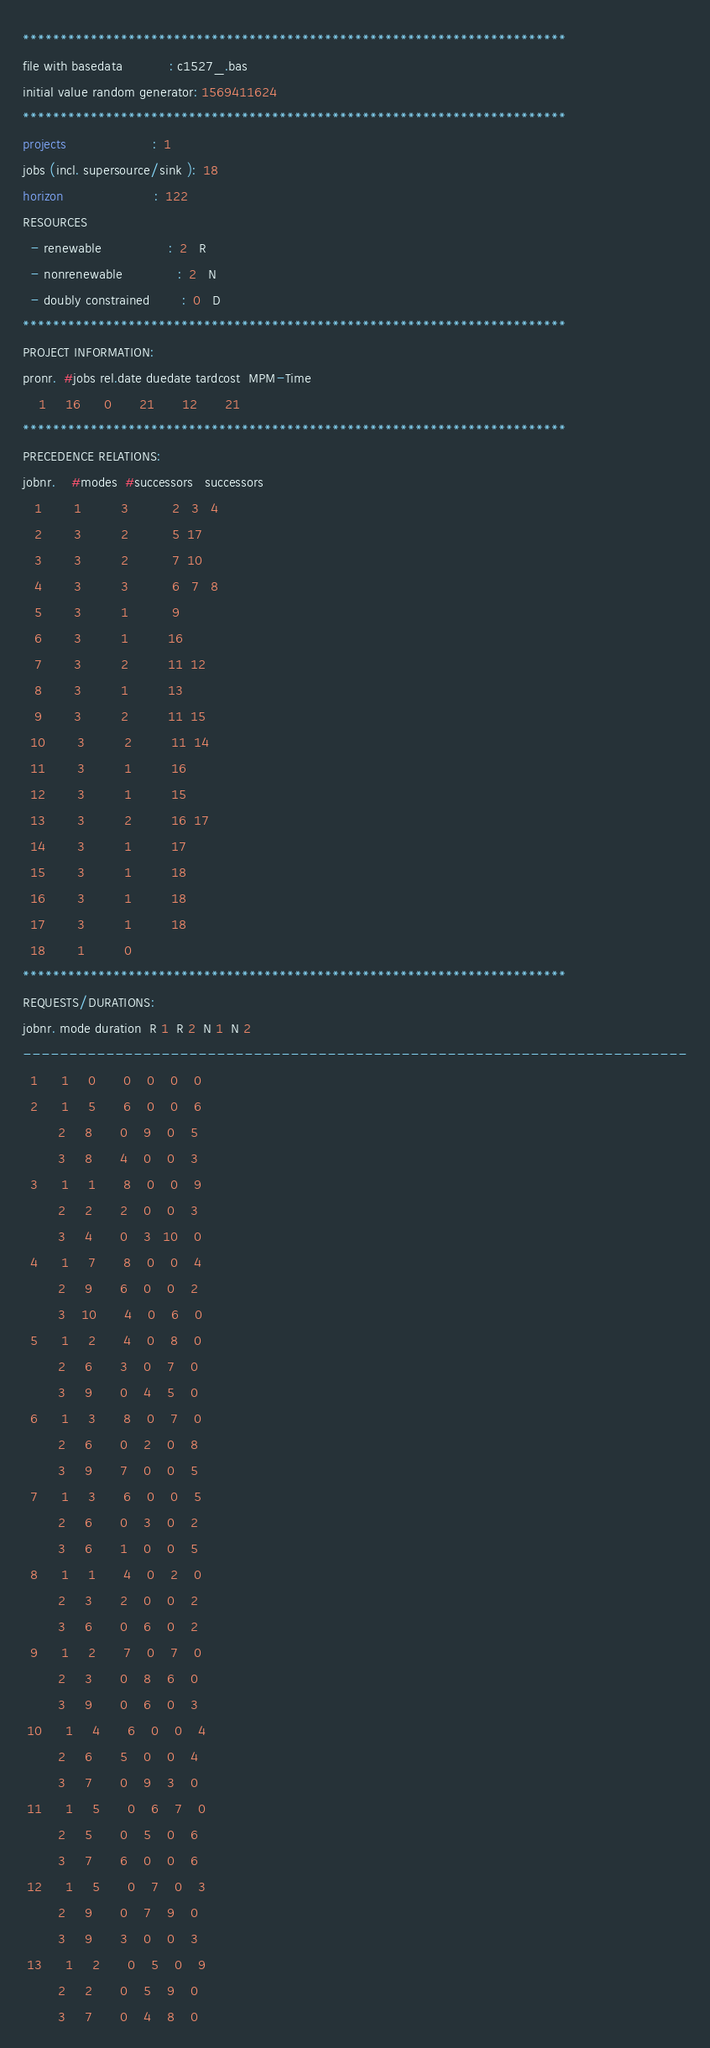<code> <loc_0><loc_0><loc_500><loc_500><_ObjectiveC_>************************************************************************
file with basedata            : c1527_.bas
initial value random generator: 1569411624
************************************************************************
projects                      :  1
jobs (incl. supersource/sink ):  18
horizon                       :  122
RESOURCES
  - renewable                 :  2   R
  - nonrenewable              :  2   N
  - doubly constrained        :  0   D
************************************************************************
PROJECT INFORMATION:
pronr.  #jobs rel.date duedate tardcost  MPM-Time
    1     16      0       21       12       21
************************************************************************
PRECEDENCE RELATIONS:
jobnr.    #modes  #successors   successors
   1        1          3           2   3   4
   2        3          2           5  17
   3        3          2           7  10
   4        3          3           6   7   8
   5        3          1           9
   6        3          1          16
   7        3          2          11  12
   8        3          1          13
   9        3          2          11  15
  10        3          2          11  14
  11        3          1          16
  12        3          1          15
  13        3          2          16  17
  14        3          1          17
  15        3          1          18
  16        3          1          18
  17        3          1          18
  18        1          0        
************************************************************************
REQUESTS/DURATIONS:
jobnr. mode duration  R 1  R 2  N 1  N 2
------------------------------------------------------------------------
  1      1     0       0    0    0    0
  2      1     5       6    0    0    6
         2     8       0    9    0    5
         3     8       4    0    0    3
  3      1     1       8    0    0    9
         2     2       2    0    0    3
         3     4       0    3   10    0
  4      1     7       8    0    0    4
         2     9       6    0    0    2
         3    10       4    0    6    0
  5      1     2       4    0    8    0
         2     6       3    0    7    0
         3     9       0    4    5    0
  6      1     3       8    0    7    0
         2     6       0    2    0    8
         3     9       7    0    0    5
  7      1     3       6    0    0    5
         2     6       0    3    0    2
         3     6       1    0    0    5
  8      1     1       4    0    2    0
         2     3       2    0    0    2
         3     6       0    6    0    2
  9      1     2       7    0    7    0
         2     3       0    8    6    0
         3     9       0    6    0    3
 10      1     4       6    0    0    4
         2     6       5    0    0    4
         3     7       0    9    3    0
 11      1     5       0    6    7    0
         2     5       0    5    0    6
         3     7       6    0    0    6
 12      1     5       0    7    0    3
         2     9       0    7    9    0
         3     9       3    0    0    3
 13      1     2       0    5    0    9
         2     2       0    5    9    0
         3     7       0    4    8    0</code> 